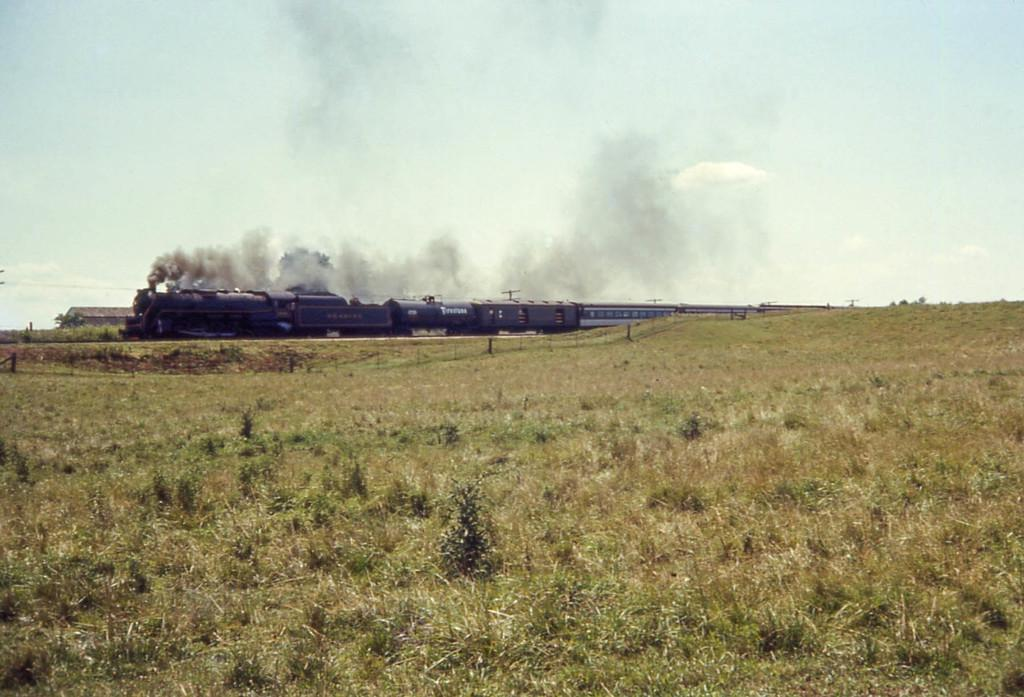What is the main subject of the picture? The main subject of the picture is a train. What can be seen in the background of the picture? There are trees behind the train. What is the train emitting in the picture? Smoke is visible in the picture. What is visible above the train in the picture? The sky is visible in the picture. How many mice can be seen running along the railway in the image? There are no mice present in the image, and the railway is not visible either. What type of waves can be seen crashing against the train in the image? There are no waves present in the image, as it features a train with trees and sky in the background. 